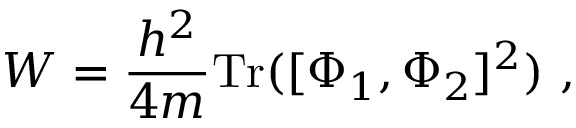<formula> <loc_0><loc_0><loc_500><loc_500>W = { \frac { h ^ { 2 } } { 4 m } } T r ( [ \Phi _ { 1 } , \Phi _ { 2 } ] ^ { 2 } ) \ ,</formula> 